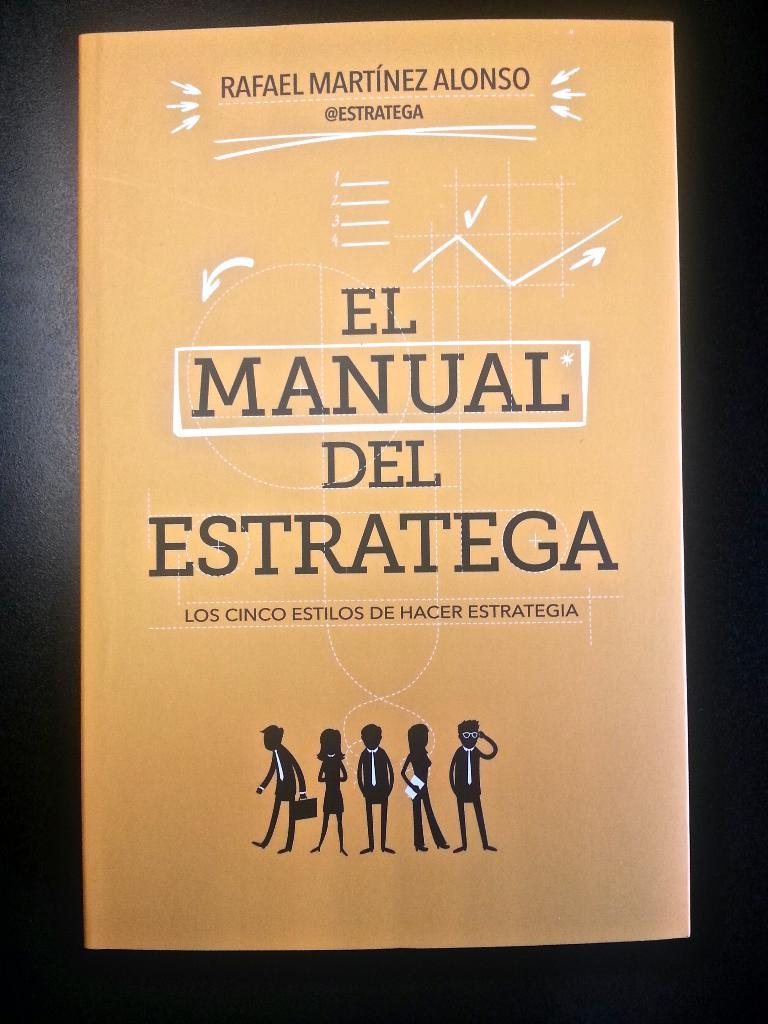<image>
Relay a brief, clear account of the picture shown. A book cover titled "El Manual Del Stratega". 